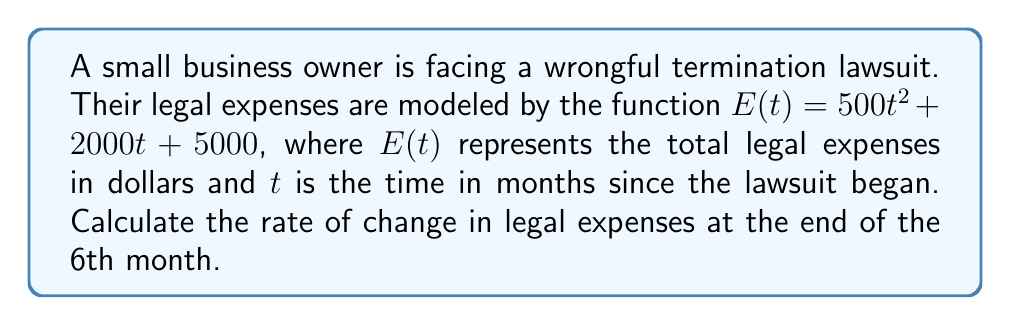Provide a solution to this math problem. To find the rate of change in legal expenses at a specific point in time, we need to calculate the derivative of the expense function $E(t)$ and then evaluate it at $t = 6$ months.

1. Given expense function: $E(t) = 500t^2 + 2000t + 5000$

2. Calculate the derivative $E'(t)$:
   $E'(t) = \frac{d}{dt}(500t^2 + 2000t + 5000)$
   $E'(t) = 1000t + 2000$

3. Evaluate $E'(t)$ at $t = 6$ months:
   $E'(6) = 1000(6) + 2000$
   $E'(6) = 6000 + 2000$
   $E'(6) = 8000$

The rate of change in legal expenses at the end of the 6th month is $8000 dollars per month.
Answer: $8000 \text{ dollars per month}$ 